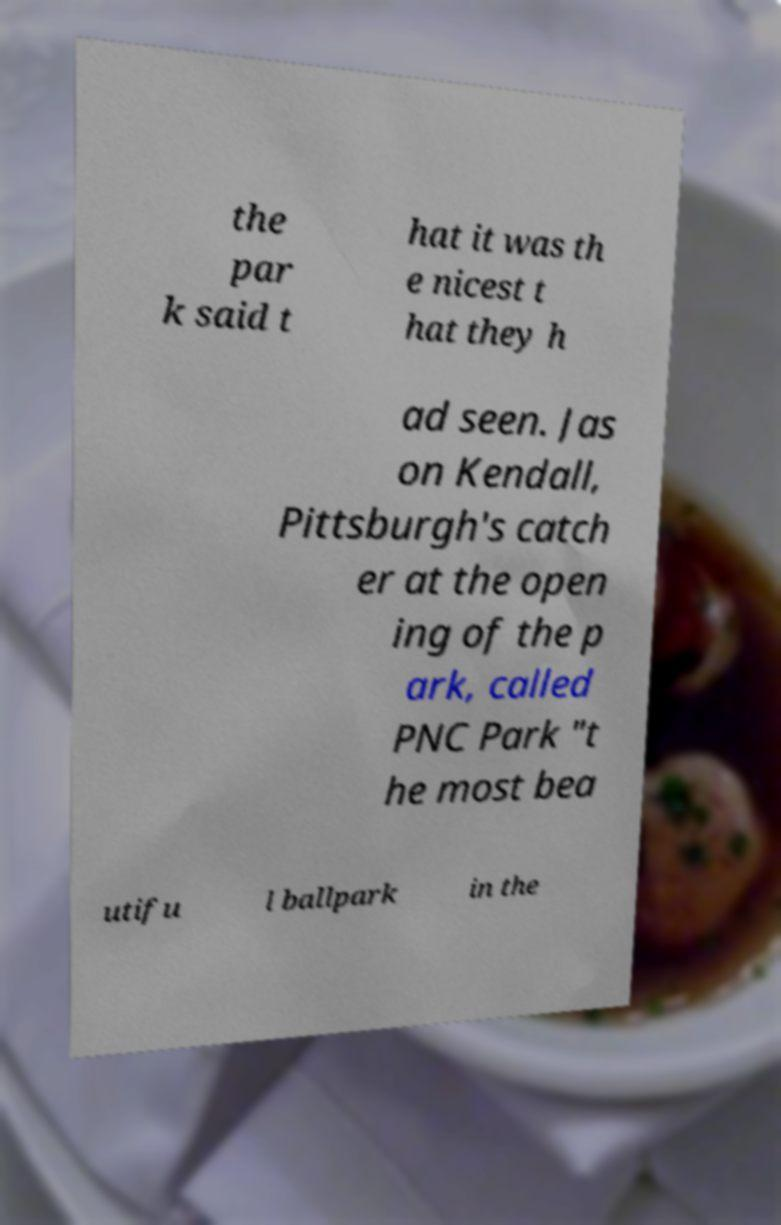Please read and relay the text visible in this image. What does it say? the par k said t hat it was th e nicest t hat they h ad seen. Jas on Kendall, Pittsburgh's catch er at the open ing of the p ark, called PNC Park "t he most bea utifu l ballpark in the 